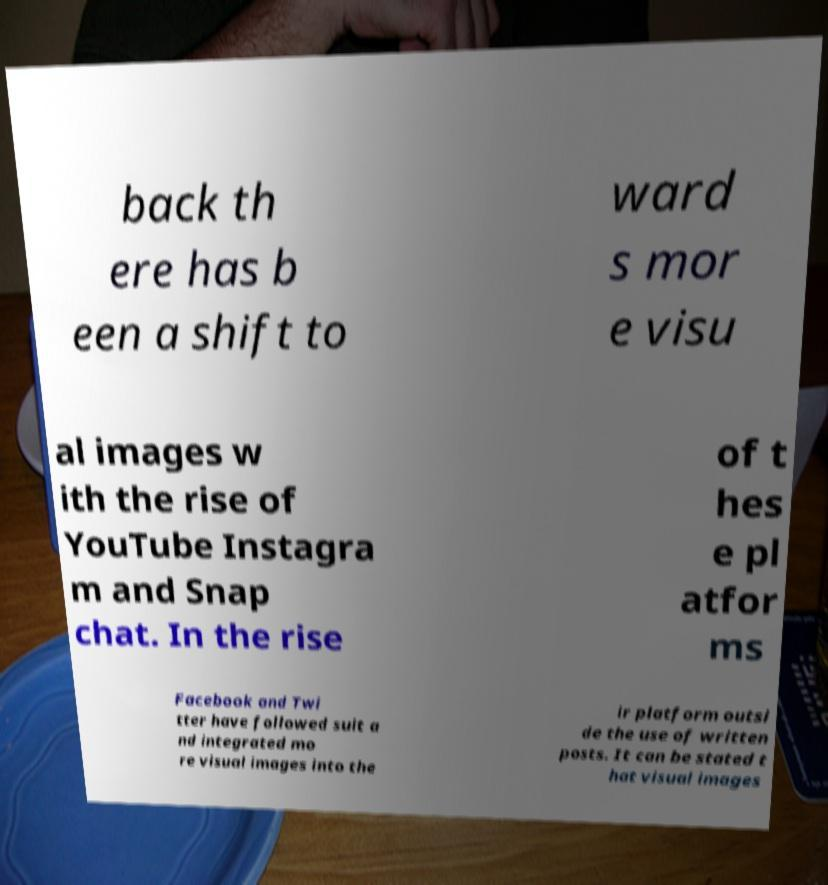Can you read and provide the text displayed in the image?This photo seems to have some interesting text. Can you extract and type it out for me? back th ere has b een a shift to ward s mor e visu al images w ith the rise of YouTube Instagra m and Snap chat. In the rise of t hes e pl atfor ms Facebook and Twi tter have followed suit a nd integrated mo re visual images into the ir platform outsi de the use of written posts. It can be stated t hat visual images 